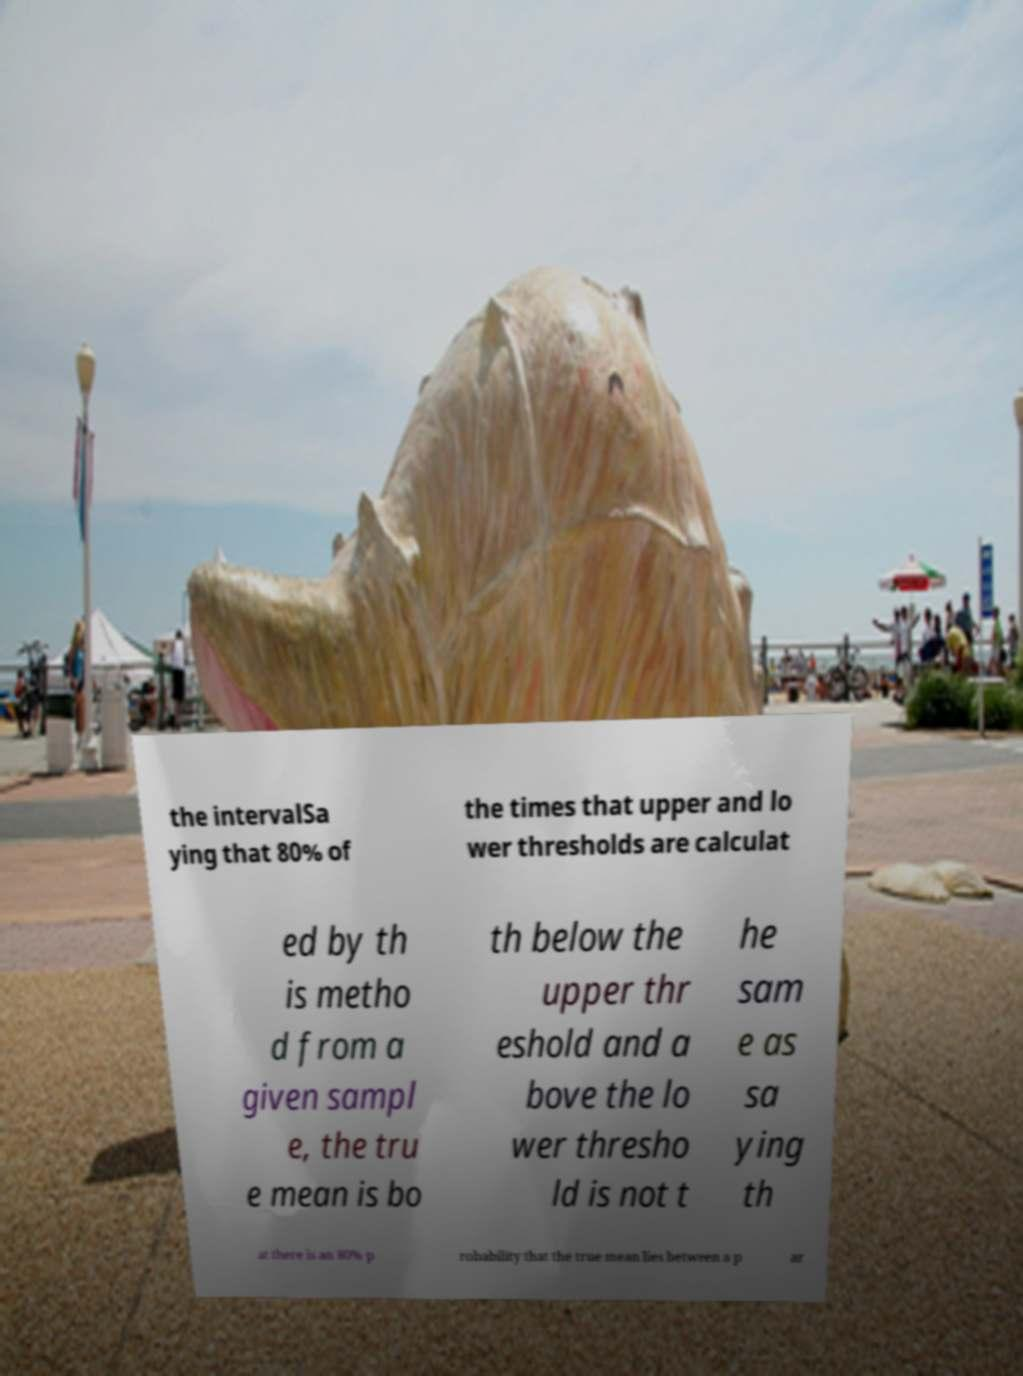There's text embedded in this image that I need extracted. Can you transcribe it verbatim? the intervalSa ying that 80% of the times that upper and lo wer thresholds are calculat ed by th is metho d from a given sampl e, the tru e mean is bo th below the upper thr eshold and a bove the lo wer thresho ld is not t he sam e as sa ying th at there is an 80% p robability that the true mean lies between a p ar 